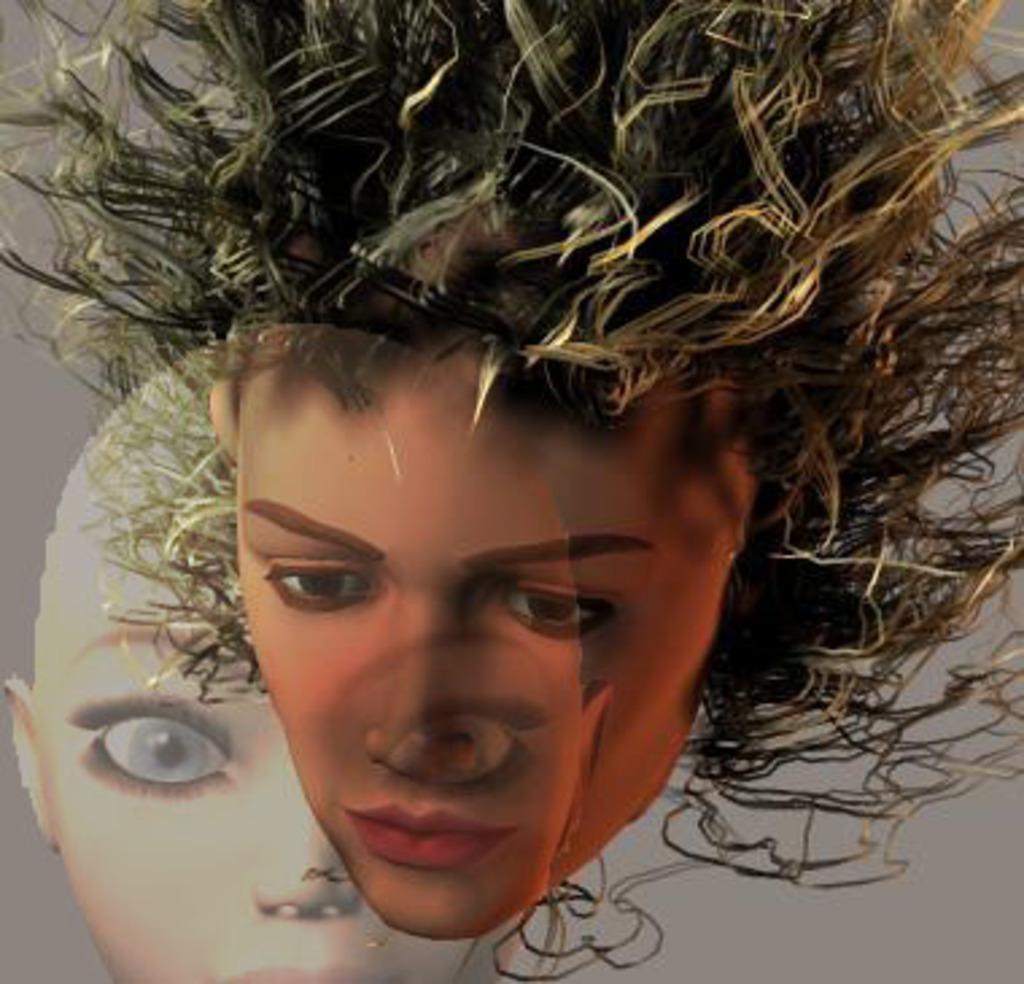Can you describe this image briefly? In this image I can see the edited picture in which I can see faces of two persons. I can see the grey colored background. 